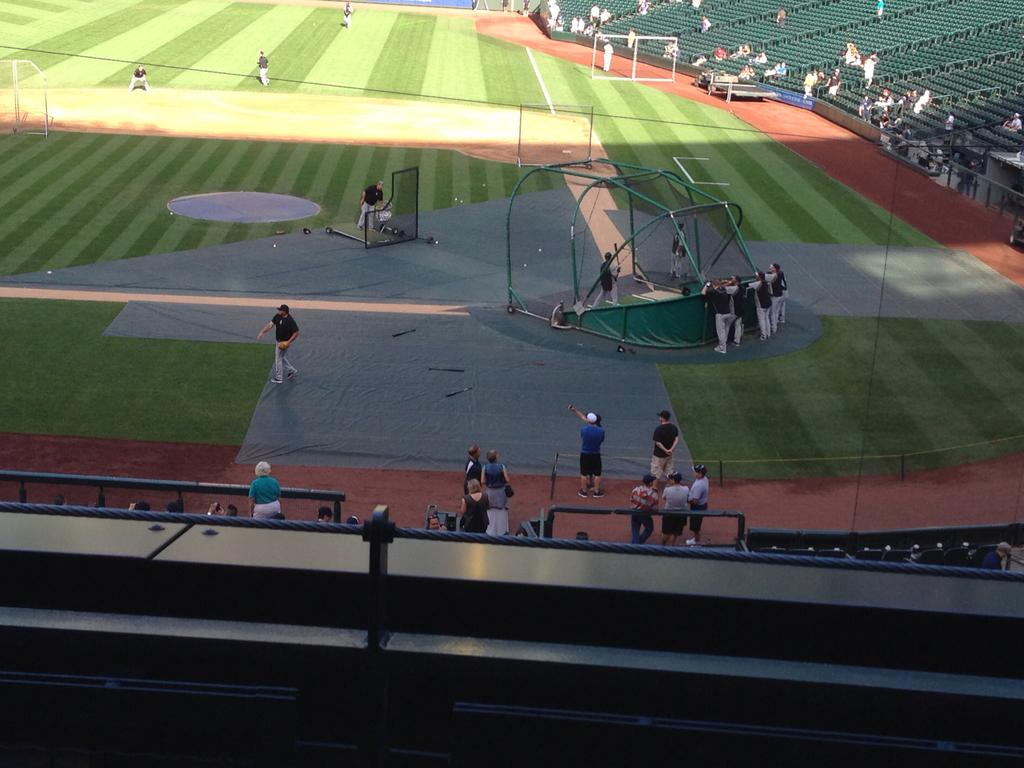What type of structure is visible in the image? There is a stadium in the image. Can you describe the people in the image? There are people in the image, but their specific actions or roles are not clear. What type of surface is the ground made of? The ground has grass. What type of sports equipment can be seen in the image? There are objects like nets and poles in the image. What type of seating is available in the image? There are chairs in the image. What type of barrier is present in the image? There is fencing in the image. What type of yarn is being used to create the patterns on the field in the image? There is no yarn or patterns on the field in the image; it is a grass surface with sports equipment. Can you see any cattle grazing on the field in the image? There are no cattle present in the image; it is a sports-related scene with a stadium, people, and sports equipment. 